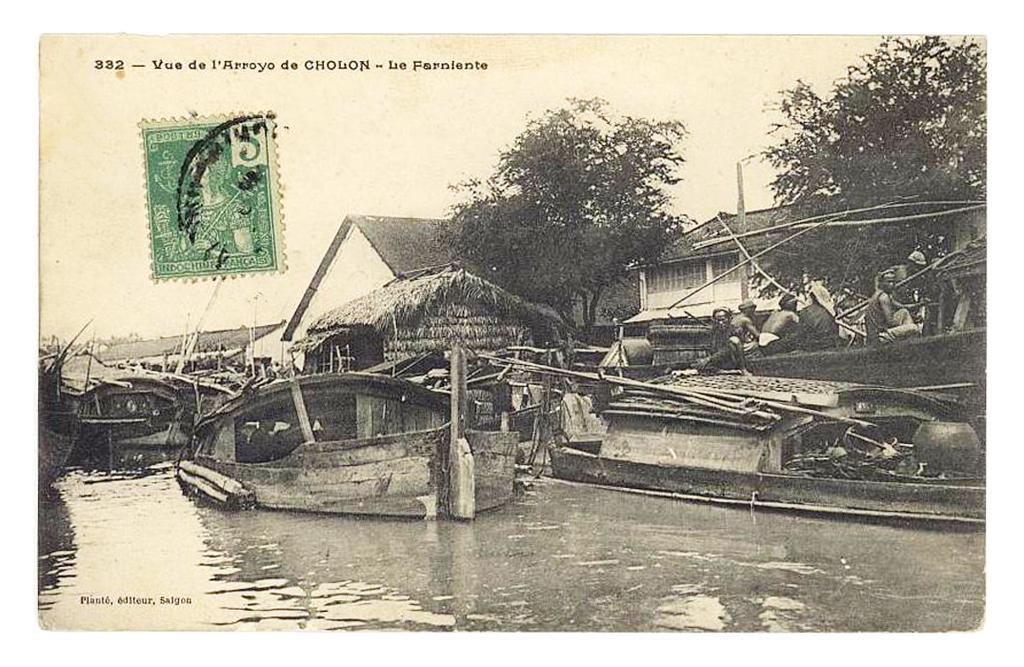Please provide a concise description of this image. As we can see in the image there is a paper. On paper there is boat, water, houses, trees and a sky. 